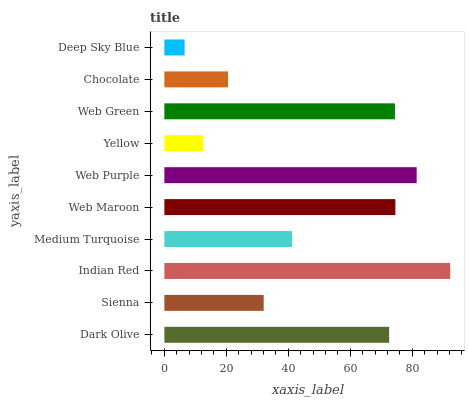Is Deep Sky Blue the minimum?
Answer yes or no. Yes. Is Indian Red the maximum?
Answer yes or no. Yes. Is Sienna the minimum?
Answer yes or no. No. Is Sienna the maximum?
Answer yes or no. No. Is Dark Olive greater than Sienna?
Answer yes or no. Yes. Is Sienna less than Dark Olive?
Answer yes or no. Yes. Is Sienna greater than Dark Olive?
Answer yes or no. No. Is Dark Olive less than Sienna?
Answer yes or no. No. Is Dark Olive the high median?
Answer yes or no. Yes. Is Medium Turquoise the low median?
Answer yes or no. Yes. Is Web Purple the high median?
Answer yes or no. No. Is Sienna the low median?
Answer yes or no. No. 